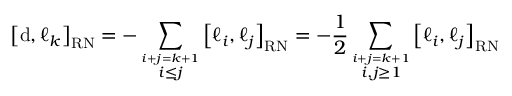Convert formula to latex. <formula><loc_0><loc_0><loc_500><loc_500>\left [ d , \ell _ { k } \right ] _ { R N } = - \sum _ { \overset { i + j = k + 1 } { i \leq j } } \left [ \ell _ { i } , \ell _ { j } \right ] _ { R N } = - \frac { 1 } { 2 } \sum _ { \overset { i + j = k + 1 } { i , j \geq 1 } } \left [ \ell _ { i } , \ell _ { j } \right ] _ { R N }</formula> 